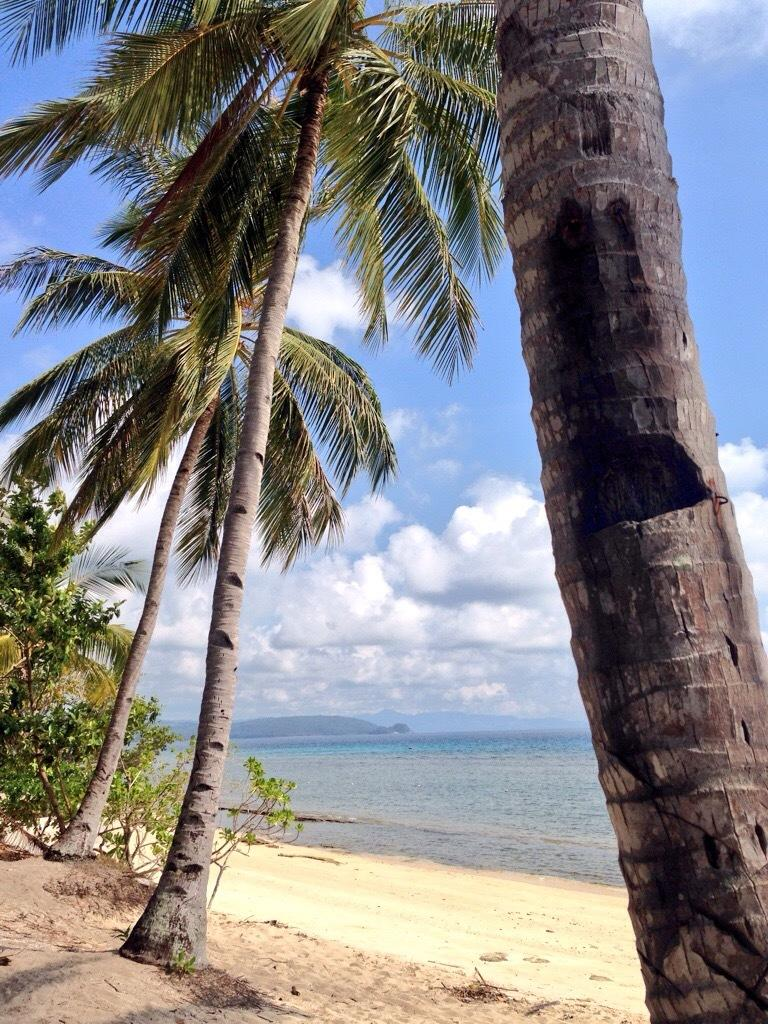What type of vegetation can be seen in the image? There are trees in the image. What natural feature is visible in the image? There is water visible in the image. What type of landscape is depicted in the image? There are hills in the image. What is visible in the background of the image? The sky is visible in the image. What type of dolls are sitting on the potato in the image? There are no dolls or potatoes present in the image. 